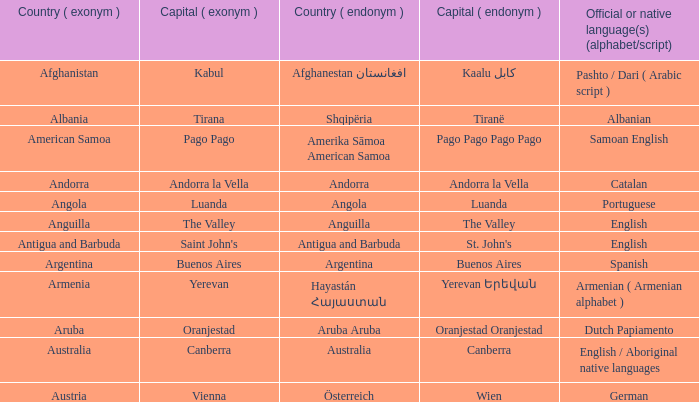How many capital cities does Australia have? 1.0. 